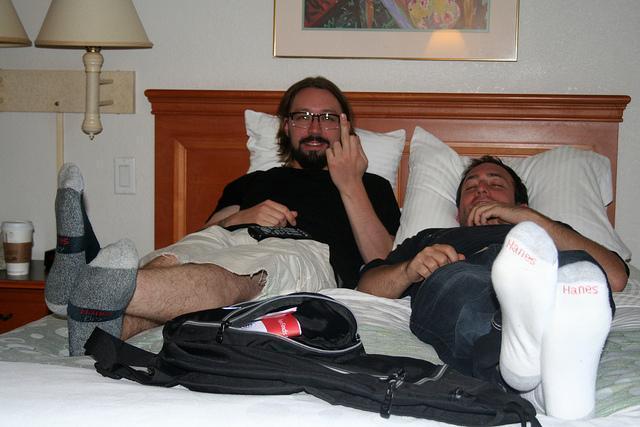How many people are there?
Give a very brief answer. 2. How many beds are visible?
Give a very brief answer. 2. How many backpacks are there?
Give a very brief answer. 1. 